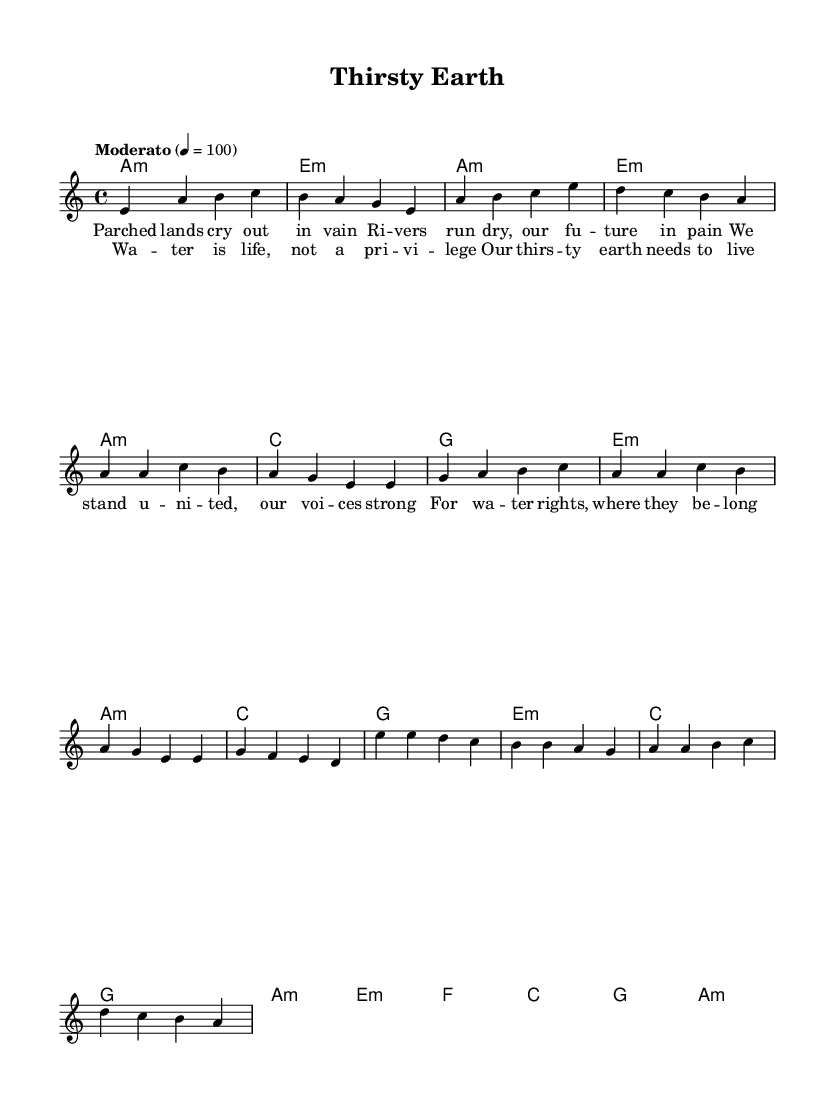What is the key signature of this music? The key signature is A minor, which has no sharps and has the same notes as C major but starts on A. This can be determined by looking at the global section of the LilyPond code where the key is defined.
Answer: A minor What is the time signature of this music? The time signature is 4/4, which means there are four beats in a measure and the quarter note receives one beat. This is indicated in the global section of the code.
Answer: 4/4 What is the tempo marking for this piece? The tempo marking is "Moderato," which indicates a moderate speed in play. This is specified in the global section of the music code.
Answer: Moderato How many measures are there in the chorus? The chorus consists of four measures, as indicated by the grouping of the notes and the section labeled for the chorus in the melody part.
Answer: Four What is a central theme emphasized in the lyrics? The central theme emphasized in the lyrics is the significance of water rights and the plea for recognizing water as a basic necessity rather than a privilege. This can be inferred from the content of the lyrics "Water is life, not a privilege."
Answer: Water rights In which section does the phrase "Our thirsty earth needs to live" appear? The phrase appears in the chorus, which is the section of the song that typically repeats the main message or theme. It is indicated in the code by the section labeled "chorus" where this specific lyric is included.
Answer: Chorus 